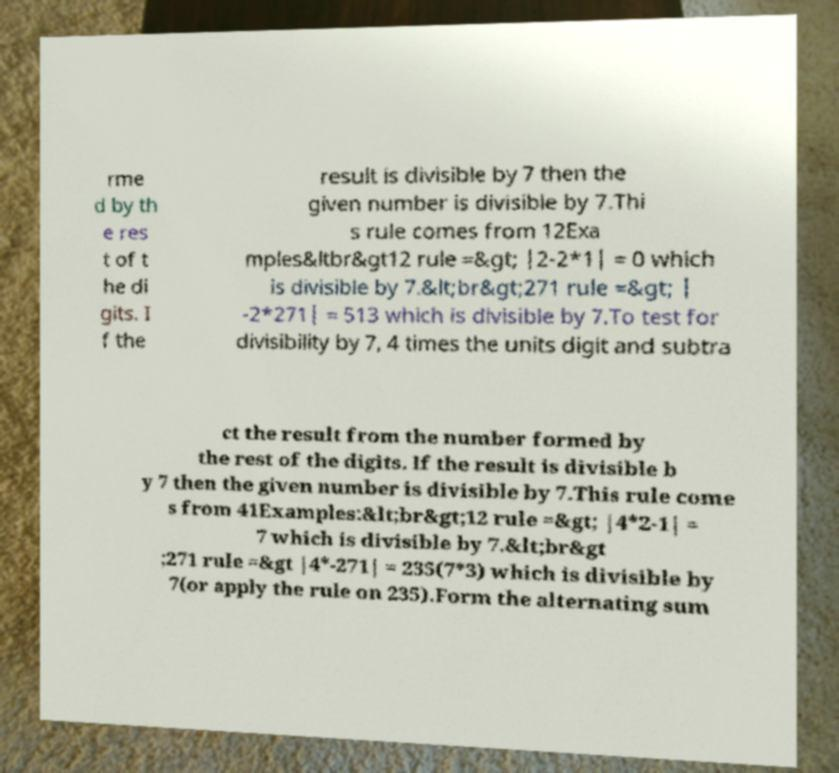There's text embedded in this image that I need extracted. Can you transcribe it verbatim? rme d by th e res t of t he di gits. I f the result is divisible by 7 then the given number is divisible by 7.Thi s rule comes from 12Exa mples&ltbr&gt12 rule =&gt; |2-2*1| = 0 which is divisible by 7.&lt;br&gt;271 rule =&gt; | -2*271| = 513 which is divisible by 7.To test for divisibility by 7, 4 times the units digit and subtra ct the result from the number formed by the rest of the digits. If the result is divisible b y 7 then the given number is divisible by 7.This rule come s from 41Examples:&lt;br&gt;12 rule =&gt; |4*2-1| = 7 which is divisible by 7.&lt;br&gt ;271 rule =&gt |4*-271| = 235(7*3) which is divisible by 7(or apply the rule on 235).Form the alternating sum 